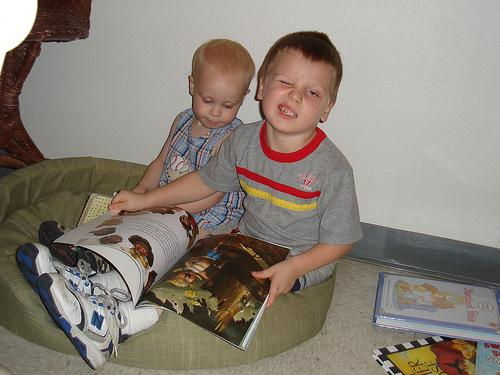Evaluate the visibility of facial features of the children in the image. The facial features of the children in the image are not clearly visible, making it difficult to discern their expressions. How many kids with grey outfits are there in the image? There are 2 kids in grey outfits. Describe any footwear visible in the image. A boy is wearing white and blue sneakers with white shoelaces. Mention the color of the shirt one of the boys is wearing and any additional details about it. One boy is wearing a gray shirt with red and yellow lines on it. What type of book are the boys reading and where is it located? The boys are reading a children's book that is opened on the floor with images inside. What activity are the two boys engaged in? The two boys are reading a book together. Provide a detailed description of the boy with blond hair. The blond-haired boy is looking at the book, wearing white and blue sneakers, and sitting on a pouf alongside another boy. What can you say about the placement of the furniture in the scene? A wooden leg of a table is visible near the two boys sitting on a pouf, and a big book is placed aside on the floor. In your own words, describe the scene involving the two boys and the book. Two curious boys are sitting together on a comfortable pouf, deeply engrossed in a children's book filled with colorful illustrations. Can you see the big red ball in the image? No, there is no big red ball visible in the image. Can you find a blue notebook on the wooden table? While there is mention of books and a wooden table leg, there is no mention of a blue notebook specifically. This instruction is misleading as it asks the viewer to look for something that may not exist in the image. Is there a girl wearing a pink dress next to the two boys? The image only shows two boys, and there is no girl wearing a pink dress visible. This instruction would make the viewer look for something that does not exist in the image. 